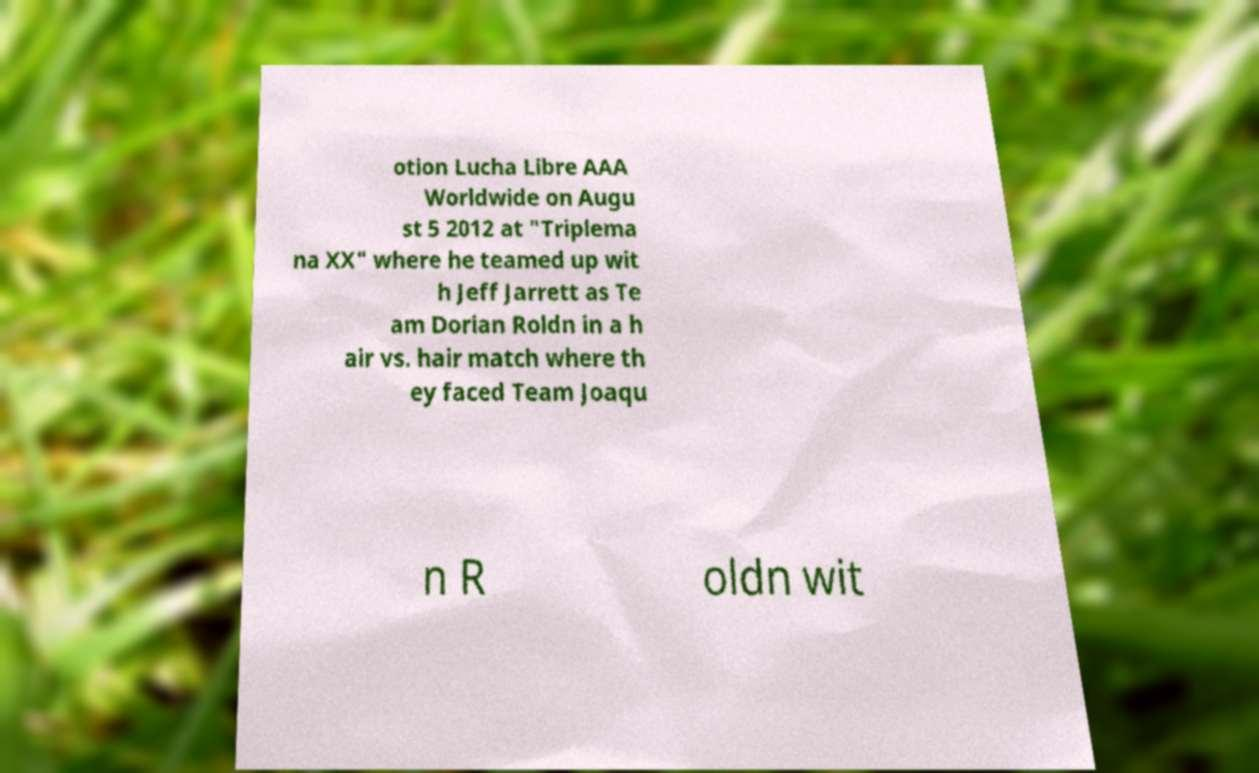Could you assist in decoding the text presented in this image and type it out clearly? otion Lucha Libre AAA Worldwide on Augu st 5 2012 at "Triplema na XX" where he teamed up wit h Jeff Jarrett as Te am Dorian Roldn in a h air vs. hair match where th ey faced Team Joaqu n R oldn wit 